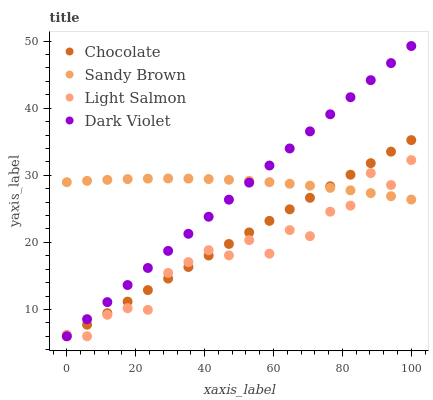Does Light Salmon have the minimum area under the curve?
Answer yes or no. Yes. Does Sandy Brown have the maximum area under the curve?
Answer yes or no. Yes. Does Dark Violet have the minimum area under the curve?
Answer yes or no. No. Does Dark Violet have the maximum area under the curve?
Answer yes or no. No. Is Chocolate the smoothest?
Answer yes or no. Yes. Is Light Salmon the roughest?
Answer yes or no. Yes. Is Sandy Brown the smoothest?
Answer yes or no. No. Is Sandy Brown the roughest?
Answer yes or no. No. Does Light Salmon have the lowest value?
Answer yes or no. Yes. Does Sandy Brown have the lowest value?
Answer yes or no. No. Does Dark Violet have the highest value?
Answer yes or no. Yes. Does Sandy Brown have the highest value?
Answer yes or no. No. Does Sandy Brown intersect Chocolate?
Answer yes or no. Yes. Is Sandy Brown less than Chocolate?
Answer yes or no. No. Is Sandy Brown greater than Chocolate?
Answer yes or no. No. 